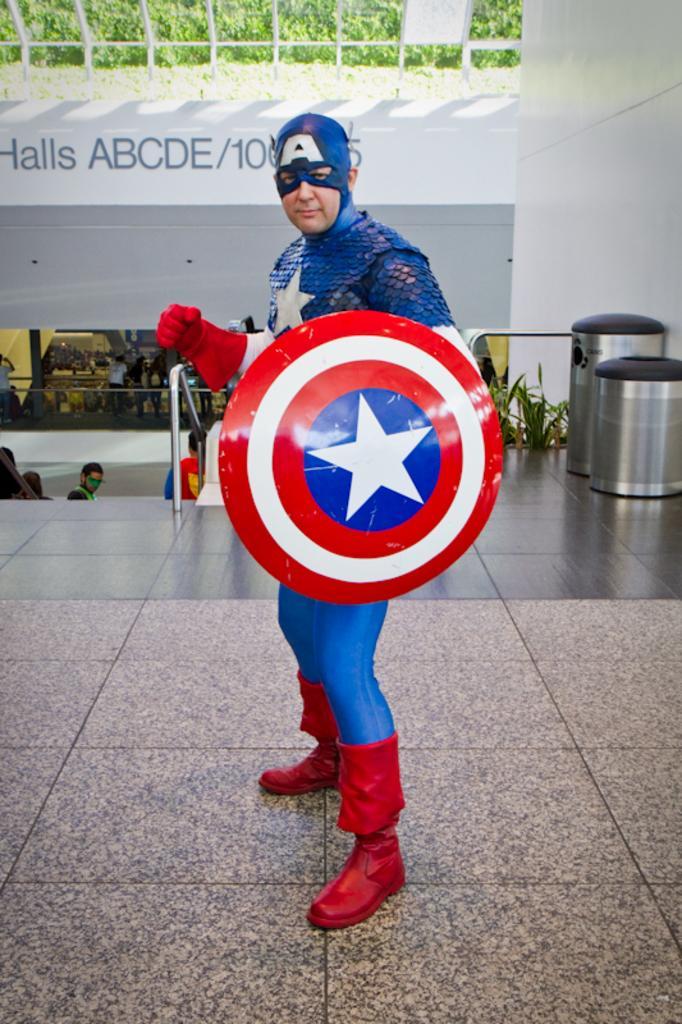In one or two sentences, can you explain what this image depicts? In this picture we can see a man is standing, he wore costumes and holding a shield, on the right side there are dustbins, it looks like a hoarding at the top of the picture, in the background there are some people standing, we can also see plants on the right side. 